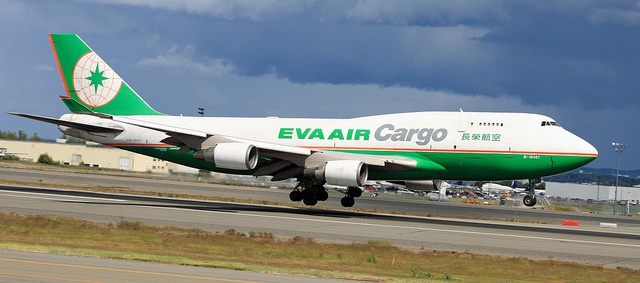Describe the objects in this image and their specific colors. I can see airplane in darkgray, white, black, and green tones and airplane in darkgray, lightgray, gray, and navy tones in this image. 